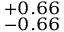Convert formula to latex. <formula><loc_0><loc_0><loc_500><loc_500>_ { - 0 . 6 6 } ^ { + 0 . 6 6 }</formula> 